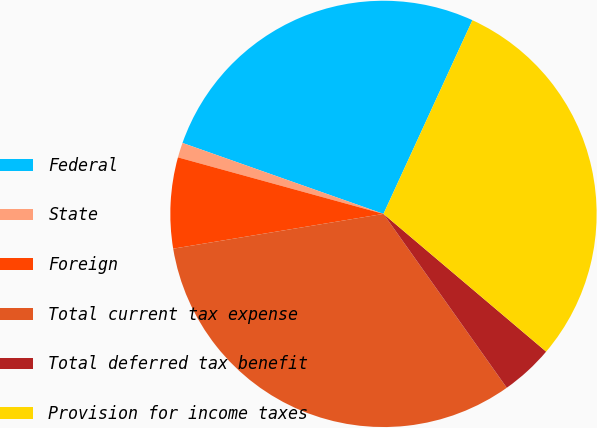<chart> <loc_0><loc_0><loc_500><loc_500><pie_chart><fcel>Federal<fcel>State<fcel>Foreign<fcel>Total current tax expense<fcel>Total deferred tax benefit<fcel>Provision for income taxes<nl><fcel>26.45%<fcel>1.13%<fcel>6.88%<fcel>32.21%<fcel>4.0%<fcel>29.33%<nl></chart> 